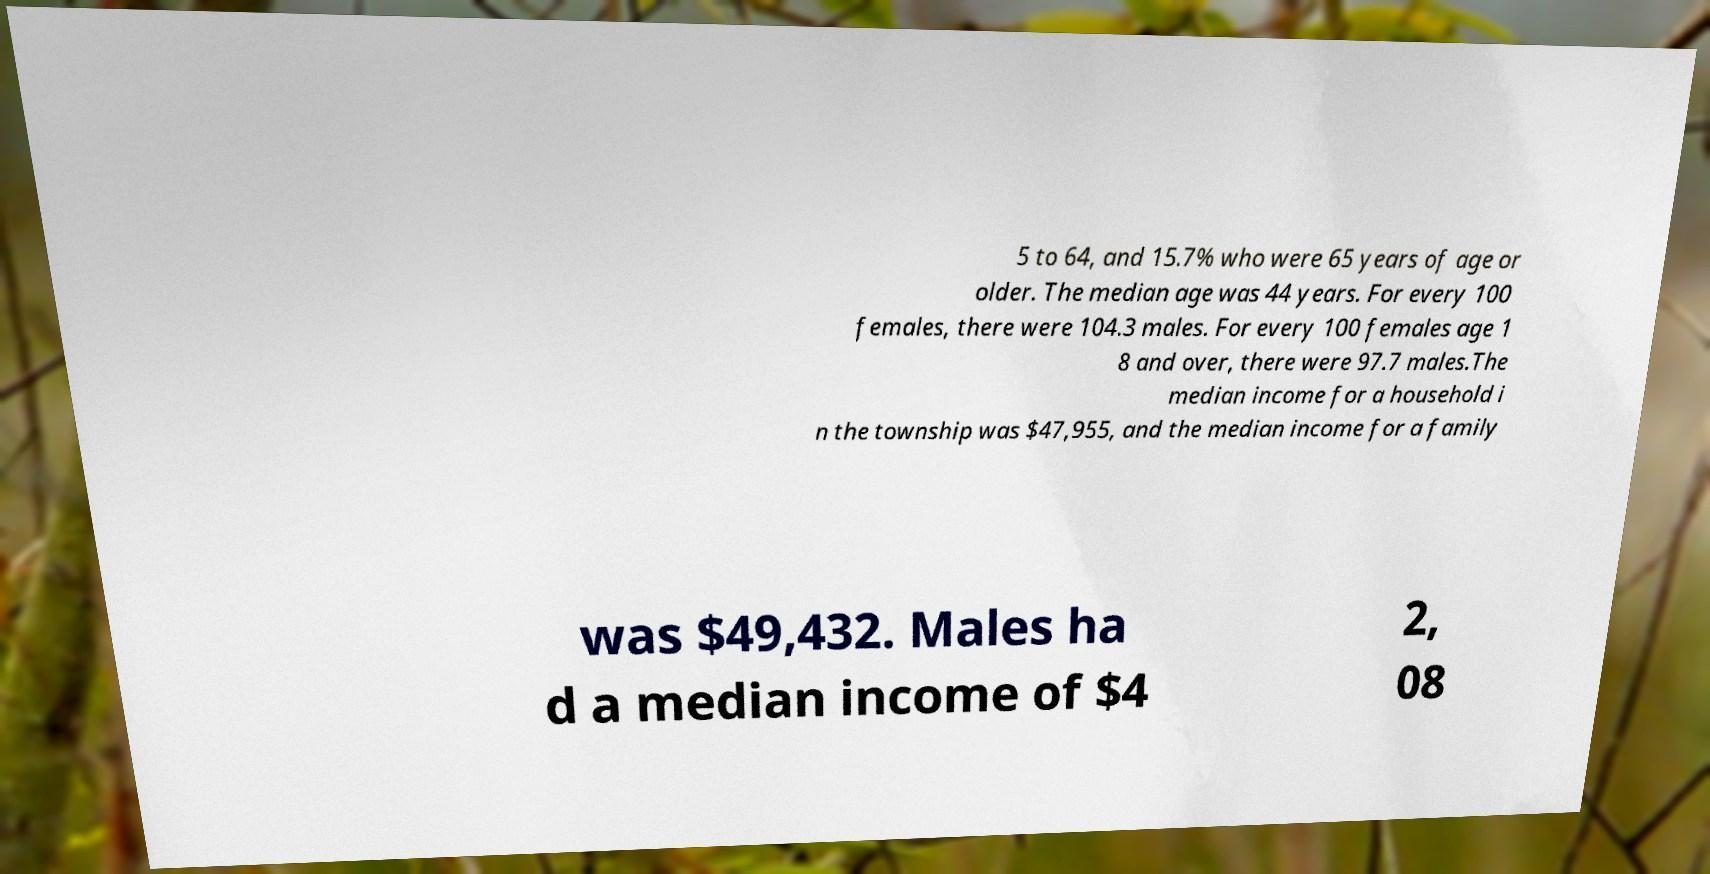Could you assist in decoding the text presented in this image and type it out clearly? 5 to 64, and 15.7% who were 65 years of age or older. The median age was 44 years. For every 100 females, there were 104.3 males. For every 100 females age 1 8 and over, there were 97.7 males.The median income for a household i n the township was $47,955, and the median income for a family was $49,432. Males ha d a median income of $4 2, 08 